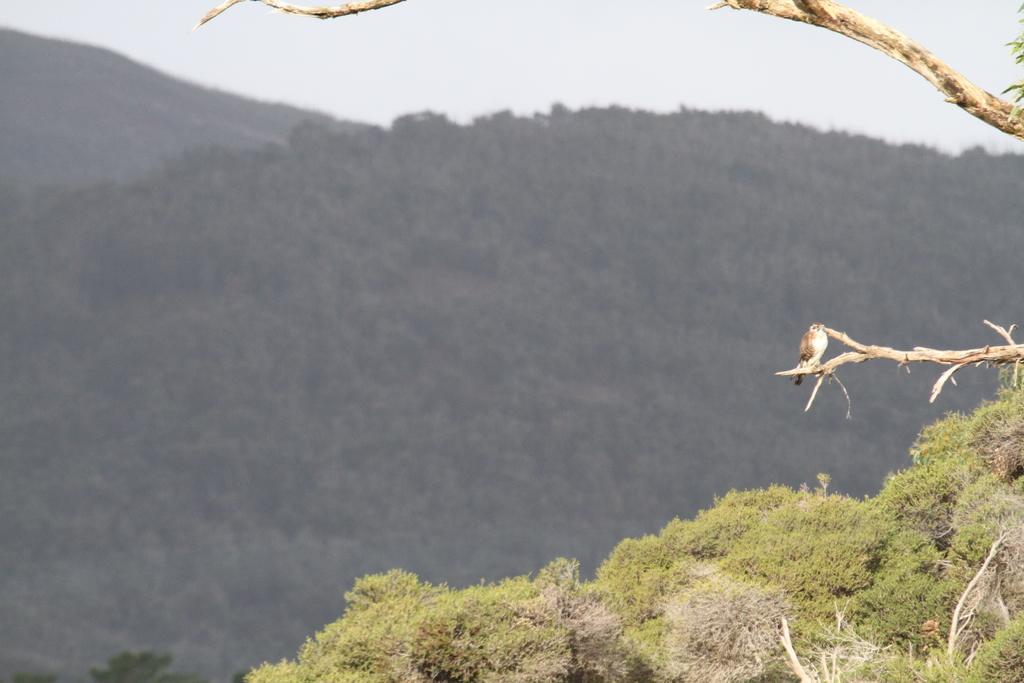Can you describe this image briefly? In this picture we can see a bird on a tree branch, mountains, grass and in the background we can see the sky. 